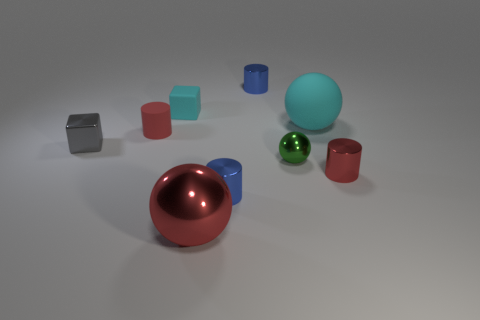There is a green thing in front of the small blue metallic object that is behind the small blue shiny cylinder in front of the small matte cylinder; what is its shape?
Keep it short and to the point. Sphere. Do the cyan object right of the tiny green ball and the small shiny thing behind the shiny cube have the same shape?
Make the answer very short. No. Is there any other thing that is the same size as the cyan ball?
Ensure brevity in your answer.  Yes. What number of balls are small red things or blue things?
Give a very brief answer. 0. Do the green sphere and the red sphere have the same material?
Provide a short and direct response. Yes. How many other objects are the same color as the rubber ball?
Your response must be concise. 1. The blue metal object that is behind the matte cube has what shape?
Provide a short and direct response. Cylinder. What number of objects are either blue things or small yellow shiny things?
Ensure brevity in your answer.  2. Do the gray shiny block and the cyan matte thing that is left of the tiny green shiny thing have the same size?
Your answer should be compact. Yes. How many other things are there of the same material as the small sphere?
Provide a succinct answer. 5. 